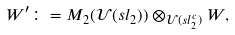<formula> <loc_0><loc_0><loc_500><loc_500>W ^ { \prime } \colon = M _ { 2 } ( \mathcal { U } ( s l _ { 2 } ) ) \otimes _ { \mathcal { U } ( s l _ { 2 } ^ { c } ) } W ,</formula> 